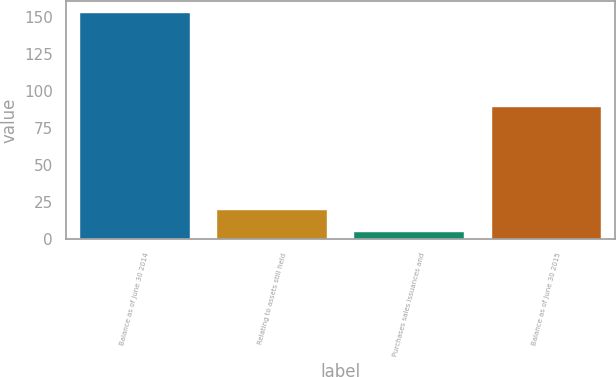<chart> <loc_0><loc_0><loc_500><loc_500><bar_chart><fcel>Balance as of June 30 2014<fcel>Relating to assets still held<fcel>Purchases sales issuances and<fcel>Balance as of June 30 2015<nl><fcel>152.7<fcel>19.77<fcel>5<fcel>89.4<nl></chart> 